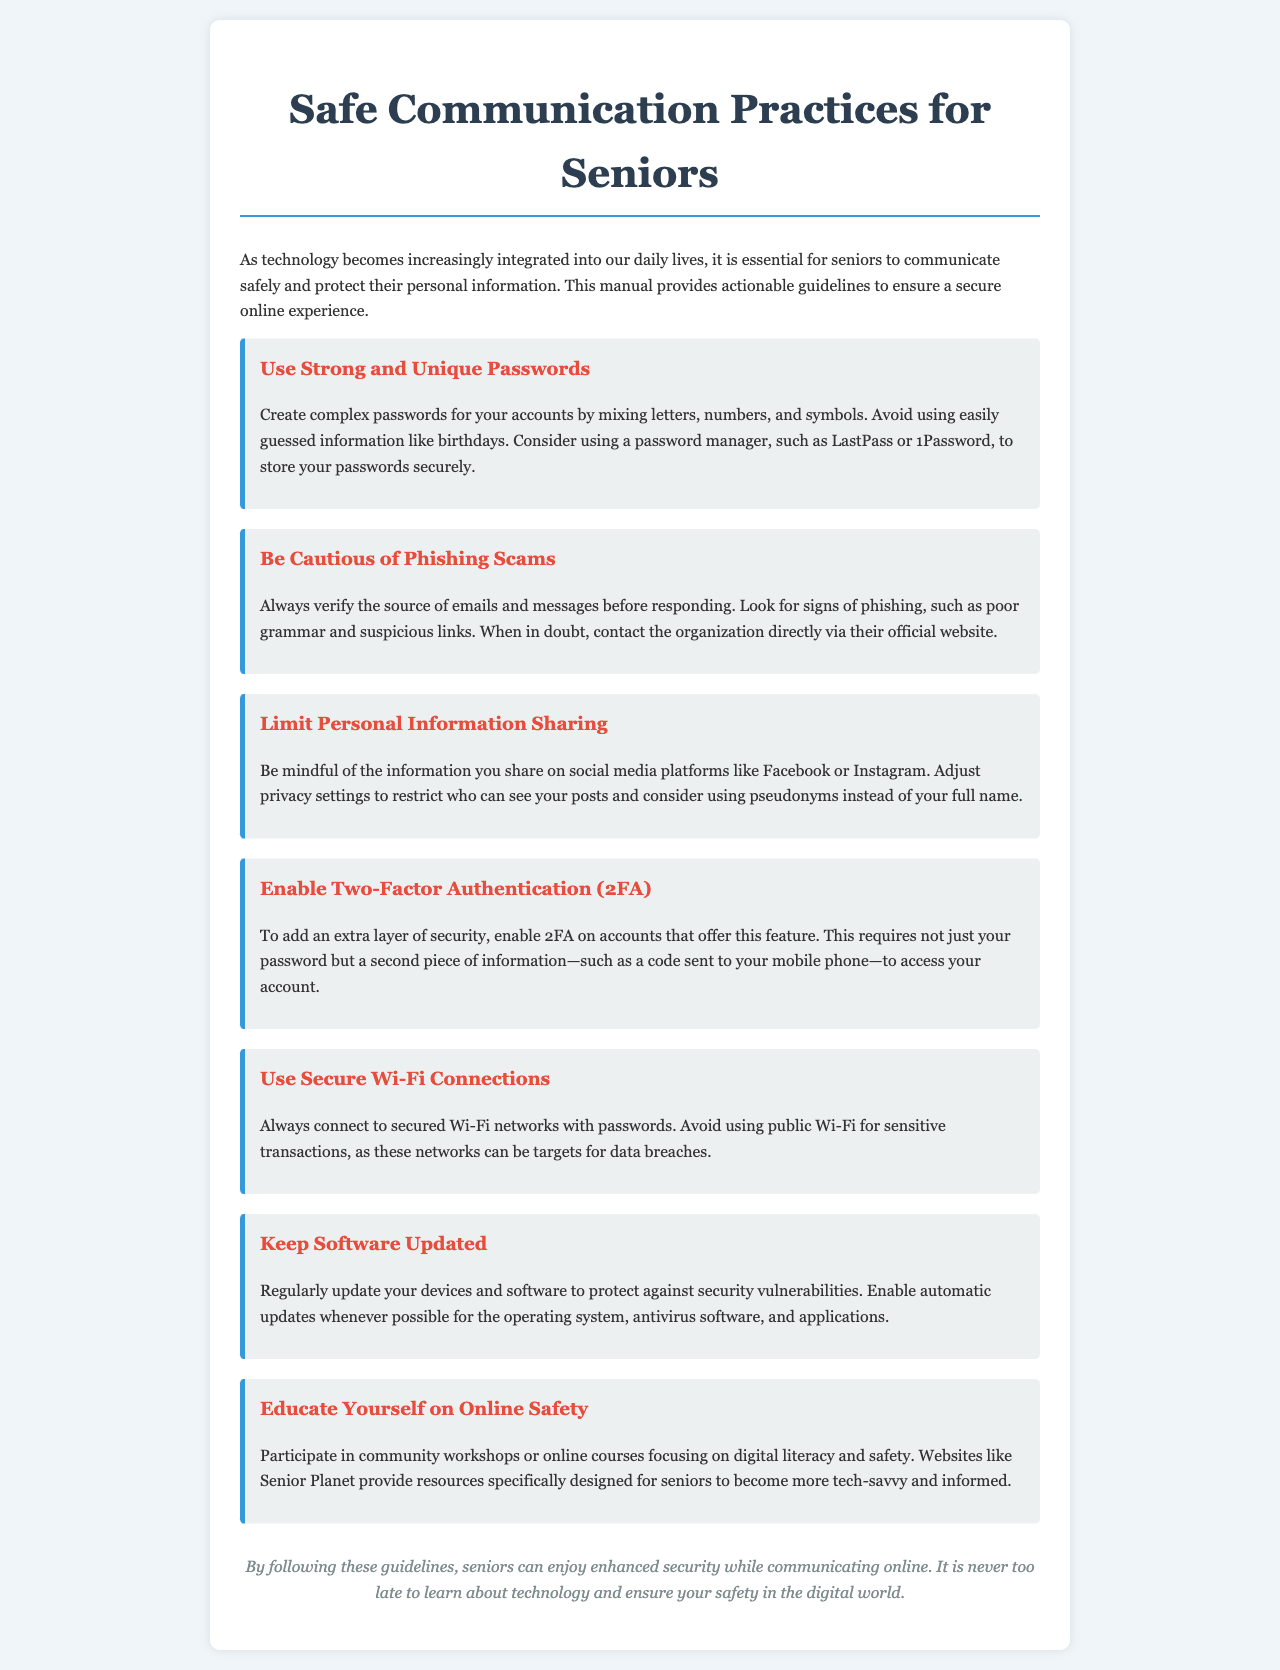What is the title of the manual? The title of the manual is stated at the top of the document.
Answer: Safe Communication Practices for Seniors How many guidelines are presented in the manual? The number of guidelines can be counted from the sections provided in the document.
Answer: Seven What should you use to create strong passwords? The manual suggests mixing letters, numbers, and symbols as part of the password creation process.
Answer: Complex passwords What does 2FA stand for? The acronym is mentioned in the section discussing security features for accounts.
Answer: Two-Factor Authentication What is a recommended resource for seniors to educate themselves on online safety? The document specifically mentions a website that provides resources for seniors.
Answer: Senior Planet What is a sign of phishing scams mentioned in the document? The document lists a characteristic that may indicate a phishing attempt.
Answer: Poor grammar What should you avoid using for sensitive transactions? The document advises against using a particular type of network.
Answer: Public Wi-Fi Which practice increases overall online security according to the manual? The manual emphasizes a specific practice that adds an extra layer of account protection.
Answer: Enable Two-Factor Authentication (2FA) 